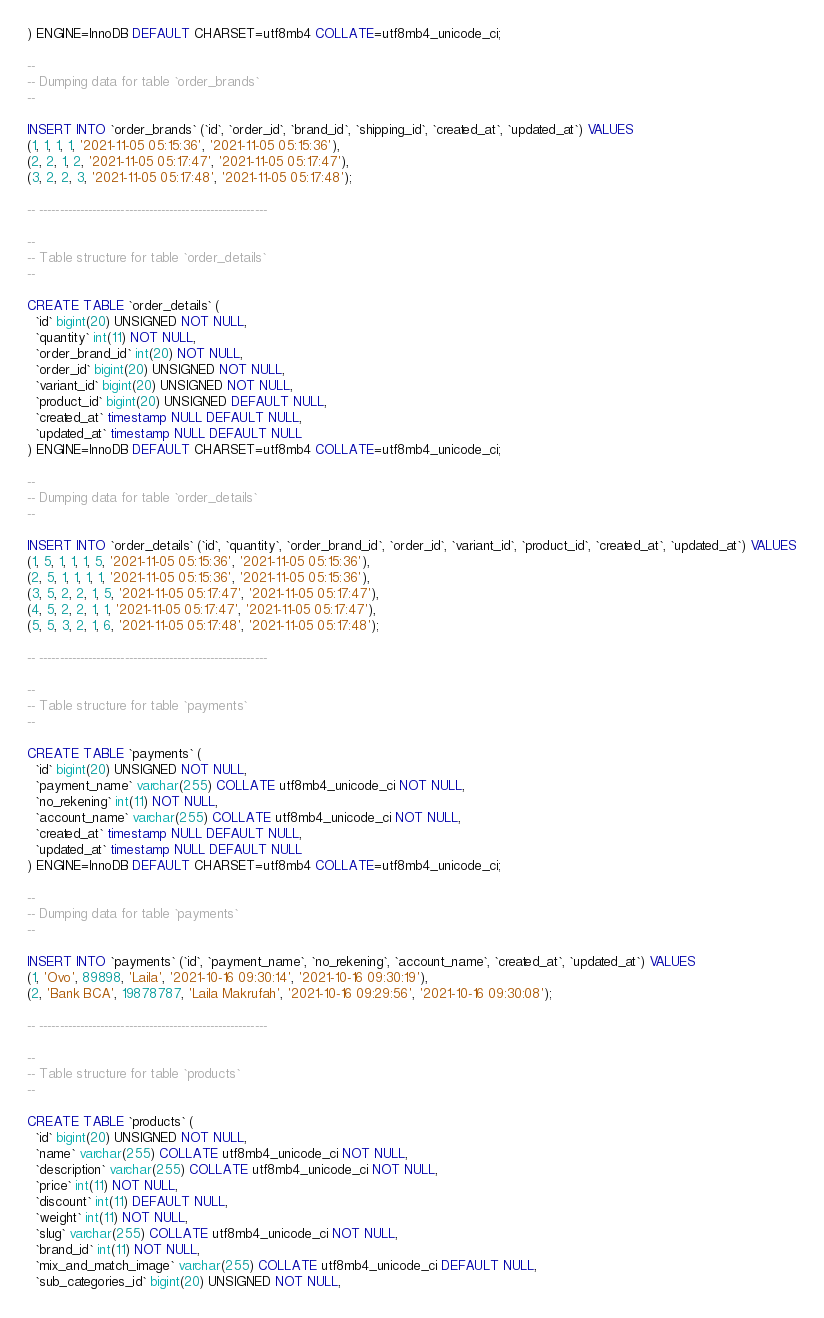<code> <loc_0><loc_0><loc_500><loc_500><_SQL_>) ENGINE=InnoDB DEFAULT CHARSET=utf8mb4 COLLATE=utf8mb4_unicode_ci;

--
-- Dumping data for table `order_brands`
--

INSERT INTO `order_brands` (`id`, `order_id`, `brand_id`, `shipping_id`, `created_at`, `updated_at`) VALUES
(1, 1, 1, 1, '2021-11-05 05:15:36', '2021-11-05 05:15:36'),
(2, 2, 1, 2, '2021-11-05 05:17:47', '2021-11-05 05:17:47'),
(3, 2, 2, 3, '2021-11-05 05:17:48', '2021-11-05 05:17:48');

-- --------------------------------------------------------

--
-- Table structure for table `order_details`
--

CREATE TABLE `order_details` (
  `id` bigint(20) UNSIGNED NOT NULL,
  `quantity` int(11) NOT NULL,
  `order_brand_id` int(20) NOT NULL,
  `order_id` bigint(20) UNSIGNED NOT NULL,
  `variant_id` bigint(20) UNSIGNED NOT NULL,
  `product_id` bigint(20) UNSIGNED DEFAULT NULL,
  `created_at` timestamp NULL DEFAULT NULL,
  `updated_at` timestamp NULL DEFAULT NULL
) ENGINE=InnoDB DEFAULT CHARSET=utf8mb4 COLLATE=utf8mb4_unicode_ci;

--
-- Dumping data for table `order_details`
--

INSERT INTO `order_details` (`id`, `quantity`, `order_brand_id`, `order_id`, `variant_id`, `product_id`, `created_at`, `updated_at`) VALUES
(1, 5, 1, 1, 1, 5, '2021-11-05 05:15:36', '2021-11-05 05:15:36'),
(2, 5, 1, 1, 1, 1, '2021-11-05 05:15:36', '2021-11-05 05:15:36'),
(3, 5, 2, 2, 1, 5, '2021-11-05 05:17:47', '2021-11-05 05:17:47'),
(4, 5, 2, 2, 1, 1, '2021-11-05 05:17:47', '2021-11-05 05:17:47'),
(5, 5, 3, 2, 1, 6, '2021-11-05 05:17:48', '2021-11-05 05:17:48');

-- --------------------------------------------------------

--
-- Table structure for table `payments`
--

CREATE TABLE `payments` (
  `id` bigint(20) UNSIGNED NOT NULL,
  `payment_name` varchar(255) COLLATE utf8mb4_unicode_ci NOT NULL,
  `no_rekening` int(11) NOT NULL,
  `account_name` varchar(255) COLLATE utf8mb4_unicode_ci NOT NULL,
  `created_at` timestamp NULL DEFAULT NULL,
  `updated_at` timestamp NULL DEFAULT NULL
) ENGINE=InnoDB DEFAULT CHARSET=utf8mb4 COLLATE=utf8mb4_unicode_ci;

--
-- Dumping data for table `payments`
--

INSERT INTO `payments` (`id`, `payment_name`, `no_rekening`, `account_name`, `created_at`, `updated_at`) VALUES
(1, 'Ovo', 89898, 'Laila', '2021-10-16 09:30:14', '2021-10-16 09:30:19'),
(2, 'Bank BCA', 19878787, 'Laila Makrufah', '2021-10-16 09:29:56', '2021-10-16 09:30:08');

-- --------------------------------------------------------

--
-- Table structure for table `products`
--

CREATE TABLE `products` (
  `id` bigint(20) UNSIGNED NOT NULL,
  `name` varchar(255) COLLATE utf8mb4_unicode_ci NOT NULL,
  `description` varchar(255) COLLATE utf8mb4_unicode_ci NOT NULL,
  `price` int(11) NOT NULL,
  `discount` int(11) DEFAULT NULL,
  `weight` int(11) NOT NULL,
  `slug` varchar(255) COLLATE utf8mb4_unicode_ci NOT NULL,
  `brand_id` int(11) NOT NULL,
  `mix_and_match_image` varchar(255) COLLATE utf8mb4_unicode_ci DEFAULT NULL,
  `sub_categories_id` bigint(20) UNSIGNED NOT NULL,</code> 